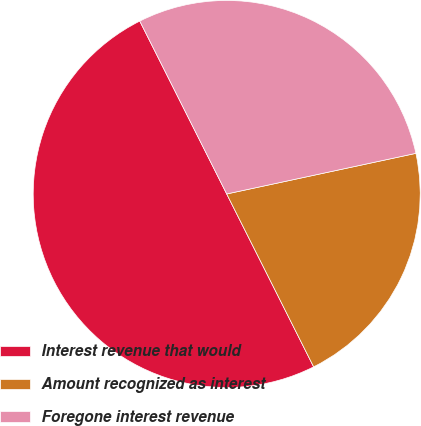Convert chart to OTSL. <chart><loc_0><loc_0><loc_500><loc_500><pie_chart><fcel>Interest revenue that would<fcel>Amount recognized as interest<fcel>Foregone interest revenue<nl><fcel>50.0%<fcel>20.95%<fcel>29.05%<nl></chart> 